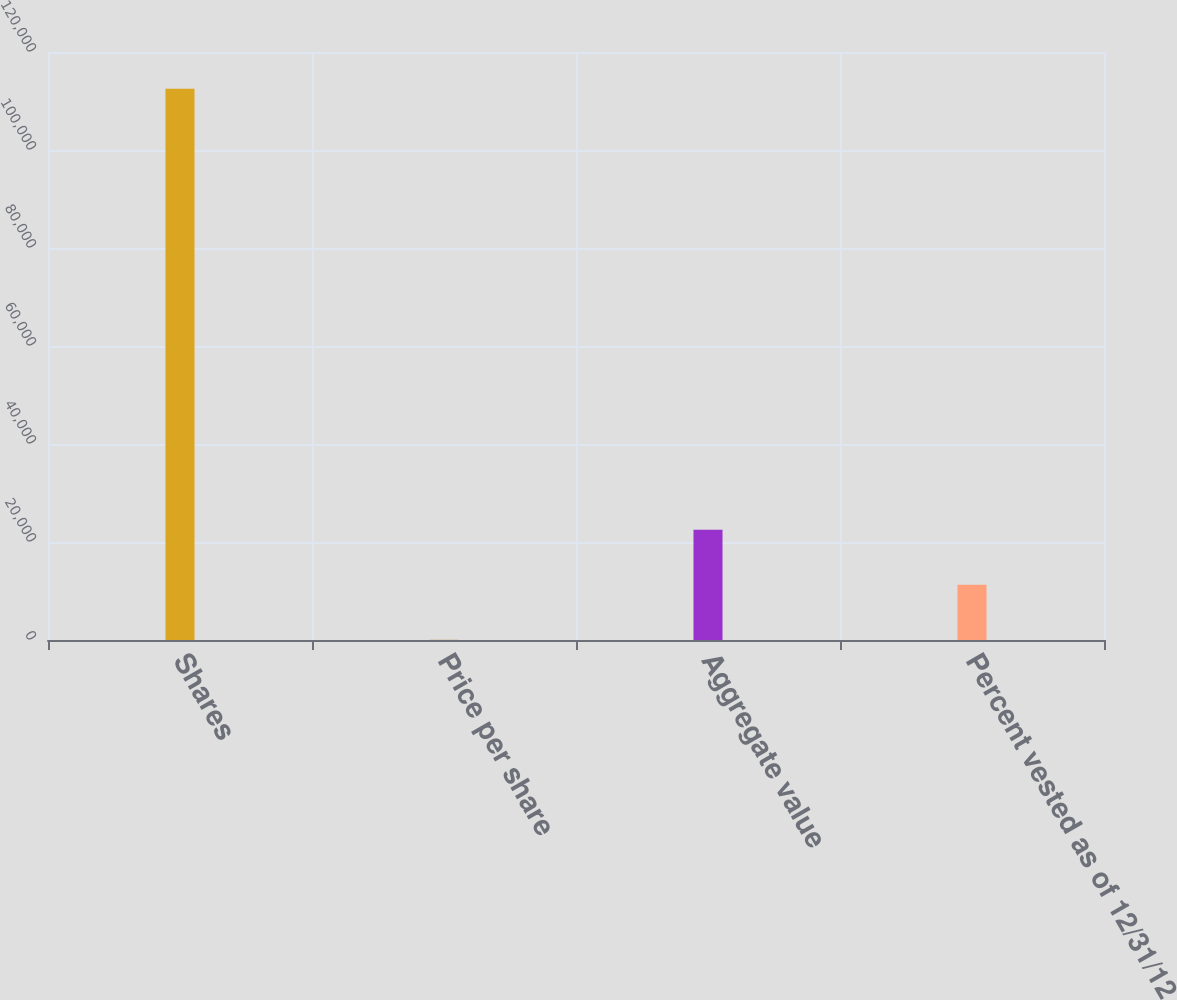Convert chart to OTSL. <chart><loc_0><loc_0><loc_500><loc_500><bar_chart><fcel>Shares<fcel>Price per share<fcel>Aggregate value<fcel>Percent vested as of 12/31/12<nl><fcel>112500<fcel>30.87<fcel>22524.7<fcel>11277.8<nl></chart> 